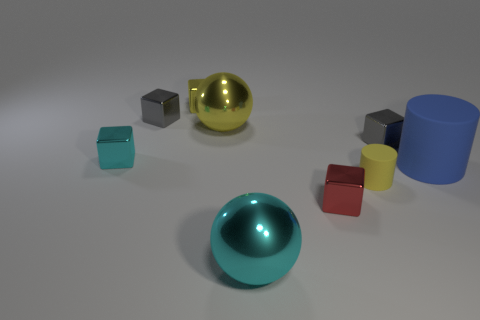The gray thing behind the gray shiny object right of the small gray shiny cube that is behind the large yellow metal object is what shape?
Provide a short and direct response. Cube. What is the material of the big ball behind the small gray object to the right of the tiny red shiny block?
Offer a terse response. Metal. What is the shape of the small yellow thing that is made of the same material as the tiny cyan object?
Your answer should be compact. Cube. Are there any other things that are the same shape as the tiny yellow rubber thing?
Keep it short and to the point. Yes. How many tiny red metallic things are left of the large yellow shiny ball?
Provide a short and direct response. 0. Are there any tiny matte cylinders?
Keep it short and to the point. Yes. There is a cylinder that is right of the gray shiny block that is in front of the big shiny ball that is behind the small cylinder; what is its color?
Offer a very short reply. Blue. There is a yellow object that is in front of the yellow metal sphere; is there a large blue cylinder behind it?
Offer a very short reply. Yes. Is the color of the large metallic object in front of the yellow metallic sphere the same as the large ball behind the tiny red thing?
Ensure brevity in your answer.  No. How many cyan balls have the same size as the yellow cylinder?
Offer a terse response. 0. 